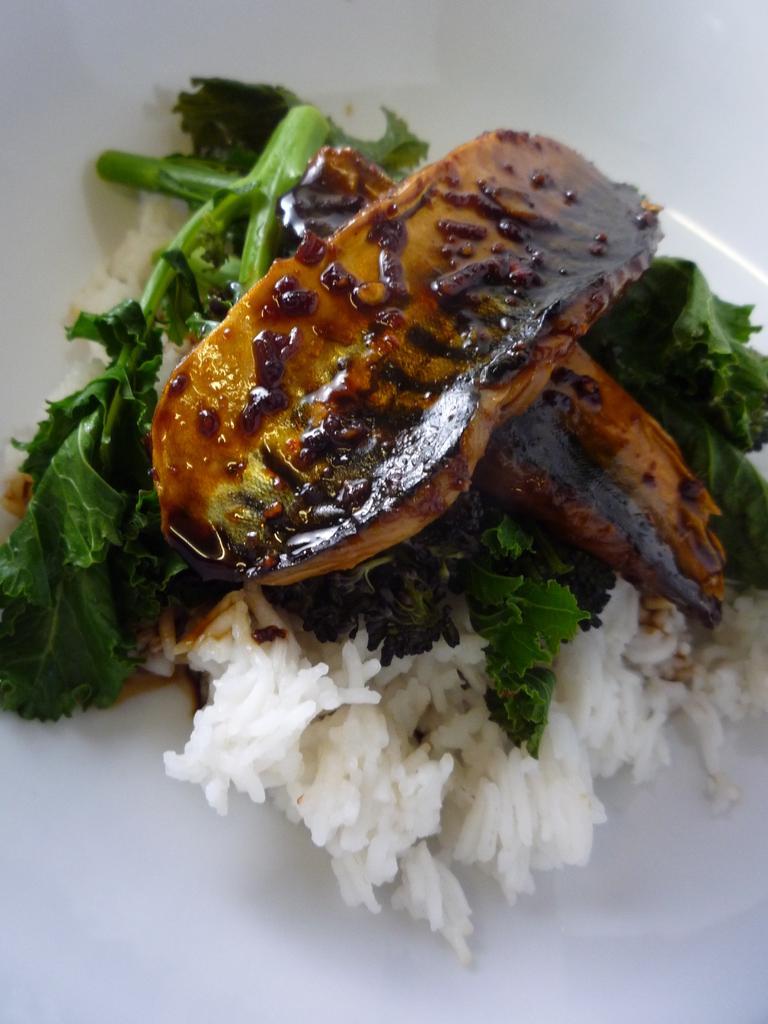Can you describe this image briefly? In this picture we can see food items on the plate. 